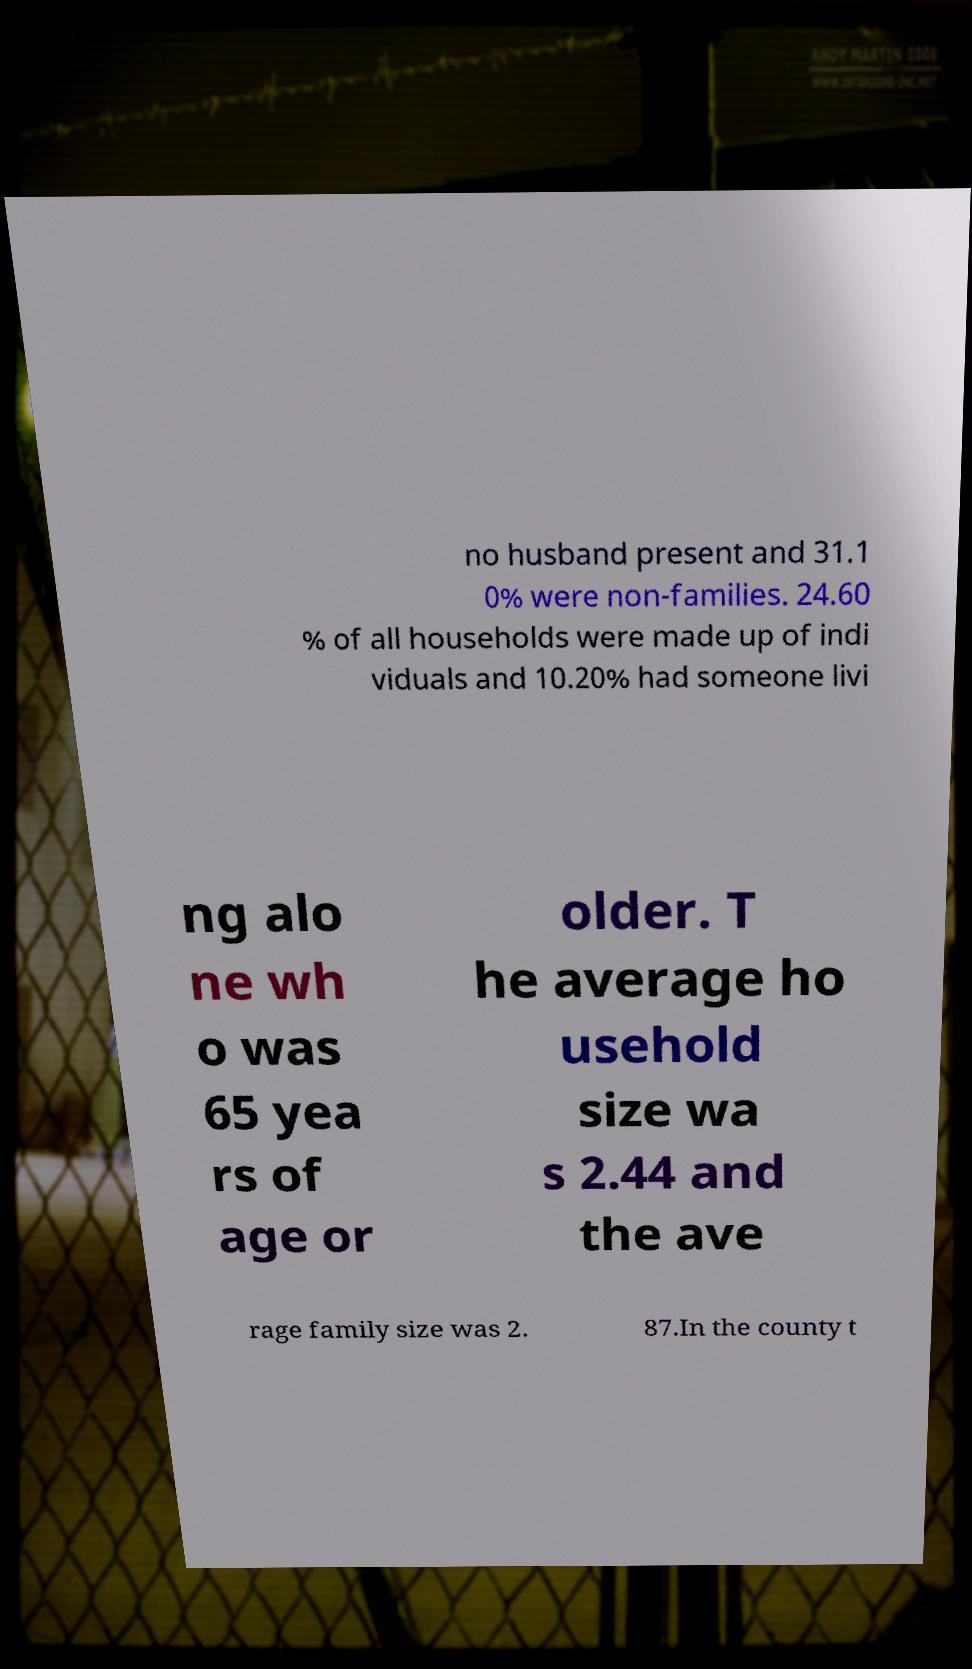There's text embedded in this image that I need extracted. Can you transcribe it verbatim? no husband present and 31.1 0% were non-families. 24.60 % of all households were made up of indi viduals and 10.20% had someone livi ng alo ne wh o was 65 yea rs of age or older. T he average ho usehold size wa s 2.44 and the ave rage family size was 2. 87.In the county t 